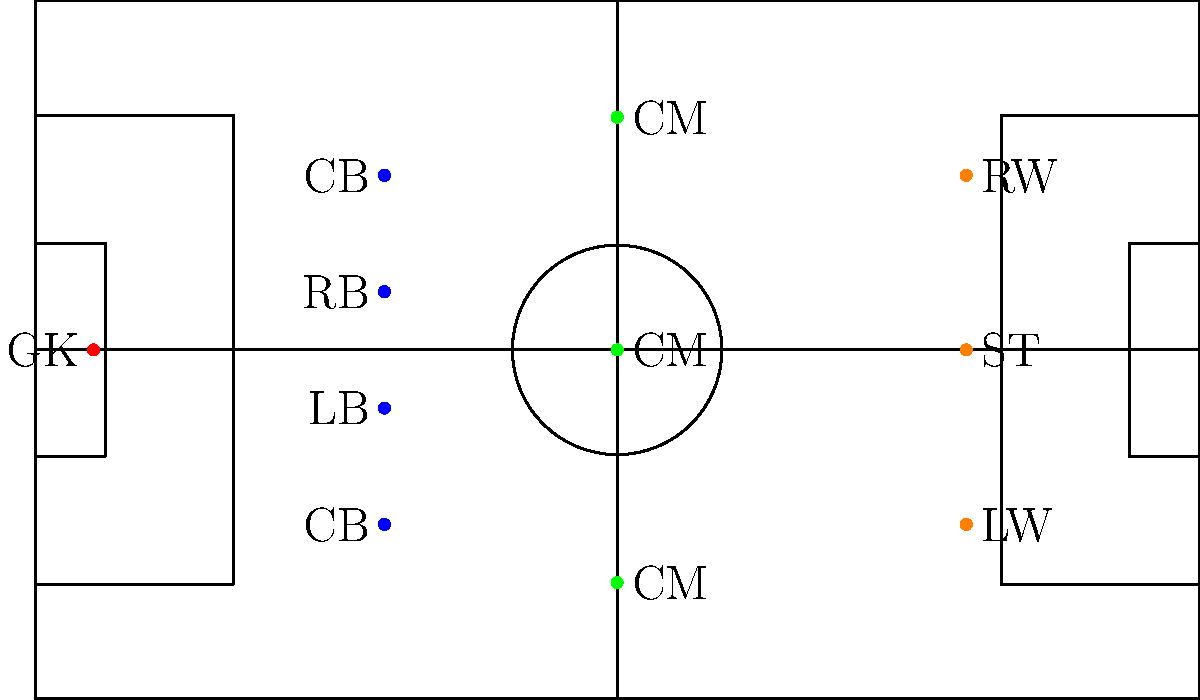Based on the diagram, which formation is Kaya-Iloilo using, and how many players are positioned in each line of play (defense, midfield, attack)? To determine the formation and player distribution, let's analyze the diagram step-by-step:

1. Goalkeeper (GK):
   - There is 1 player (red dot) positioned at the goal.

2. Defenders:
   - There are 4 players (blue dots) positioned in the defensive line.
   - 2 central defenders (CB) and 2 fullbacks (LB and RB).

3. Midfielders:
   - There are 3 players (green dots) positioned in the midfield.
   - All 3 are labeled as central midfielders (CM).

4. Attackers:
   - There are 3 players (orange dots) positioned in the attacking line.
   - 1 striker (ST) in the center, with 1 left winger (LW) and 1 right winger (RW).

5. Formation analysis:
   - The player distribution from back to front is 4-3-3.
   - This is a common attacking formation in modern football.

Therefore, Kaya-Iloilo is using a 4-3-3 formation with:
- 4 players in defense
- 3 players in midfield
- 3 players in attack
Answer: 4-3-3 formation; 4 in defense, 3 in midfield, 3 in attack 